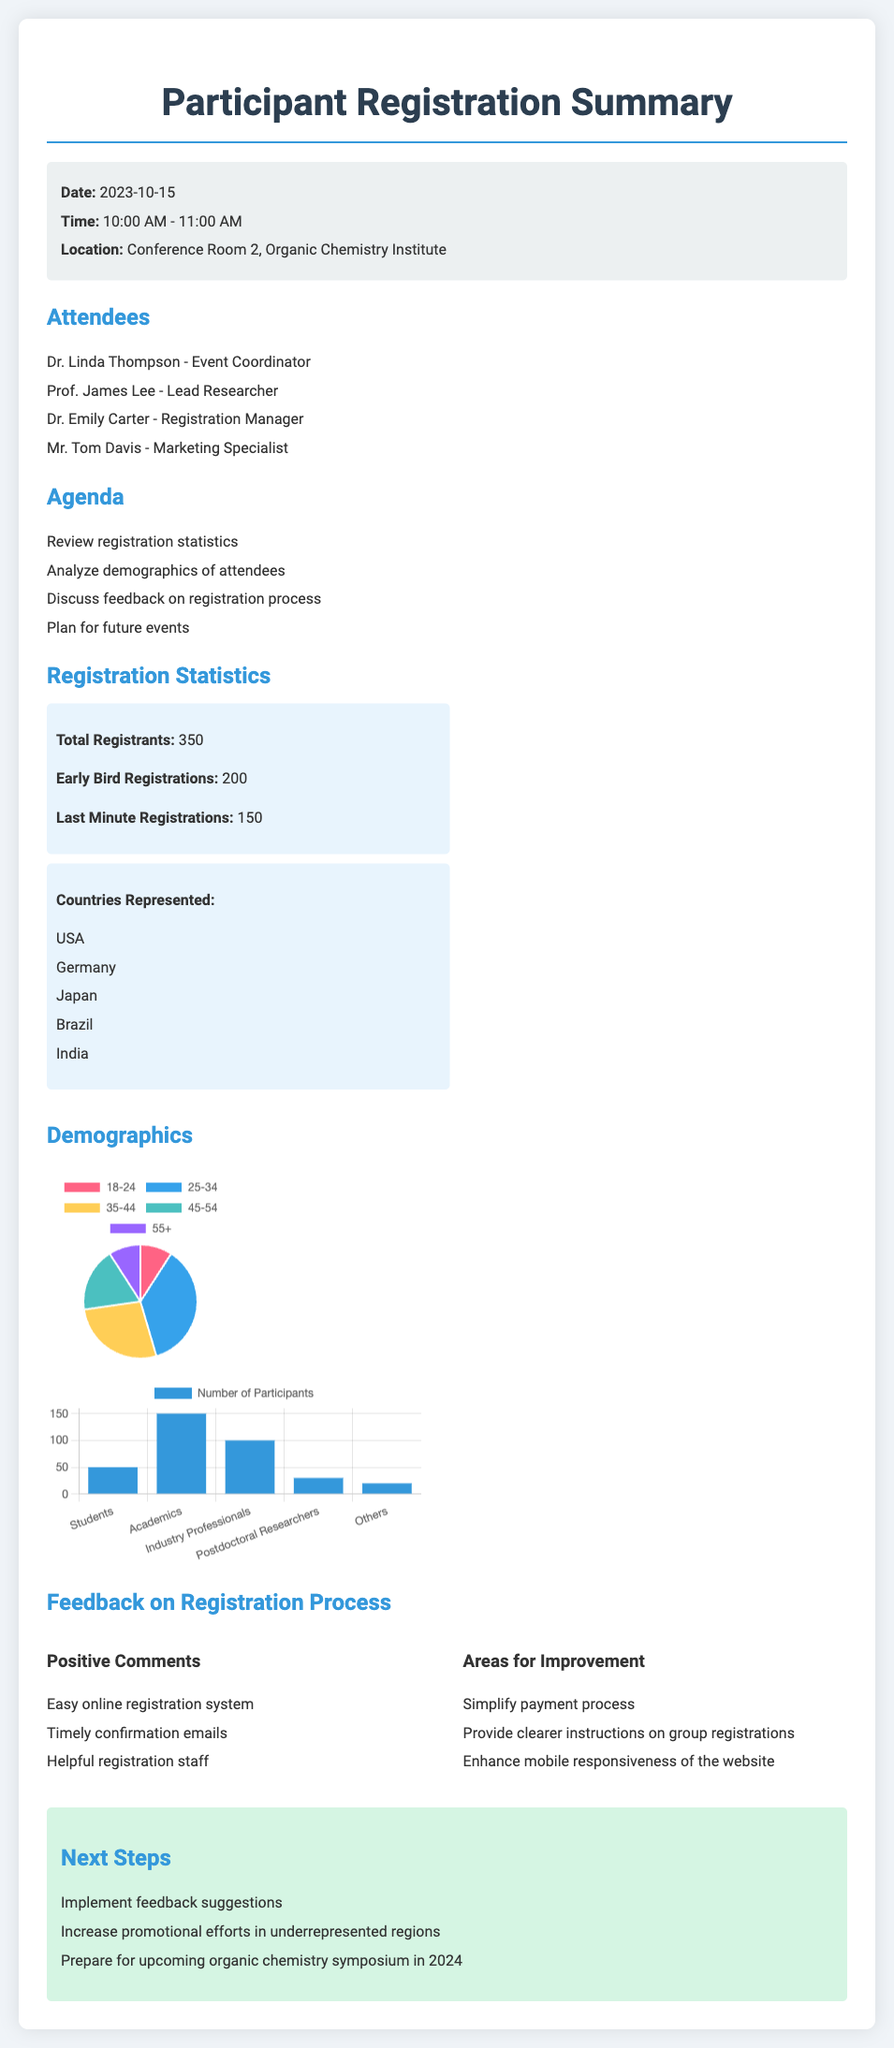What is the date of the meeting? The date of the meeting is mentioned in the meeting info section.
Answer: 2023-10-15 How many total registrants were there? The total number of registrants is provided in the registration statistics section.
Answer: 350 Which country had the highest representation? The countries represented are listed, and we infer that the USA is likely the most represented country.
Answer: USA What percentage of attendees were early bird registrations? The early bird registrations are 200 out of 350 total registrants, which gives a clear percentage.
Answer: 57% What was one positive comment about the registration process? Positive comments are listed in the feedback section, indicating participants' satisfaction.
Answer: Easy online registration system What area for improvement was mentioned? The areas for improvement are highlighted in the feedback section as suggestions for better experiences.
Answer: Simplify payment process What is the role of Dr. Linda Thompson? The roles of attendees are stated in the attendees' list, indicating their responsibilities during the meeting.
Answer: Event Coordinator How many participants were students? The profession distribution chart provides specific numbers for each profession; students have their count directly listed.
Answer: 50 What will be one of the next steps mentioned? The next steps listed in the document detail the follow-up actions to be taken post-meeting.
Answer: Implement feedback suggestions 